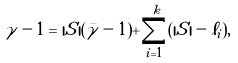<formula> <loc_0><loc_0><loc_500><loc_500>\gamma - 1 = { | S | } ( \bar { \gamma } - 1 ) + \sum _ { i = 1 } ^ { k } ( | S | - \ell _ { i } ) ,</formula> 